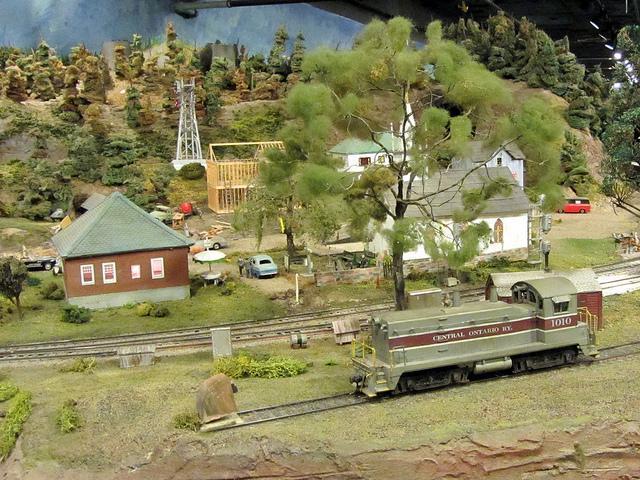How many of the benches on the boat have chains attached to them?
Give a very brief answer. 0. 